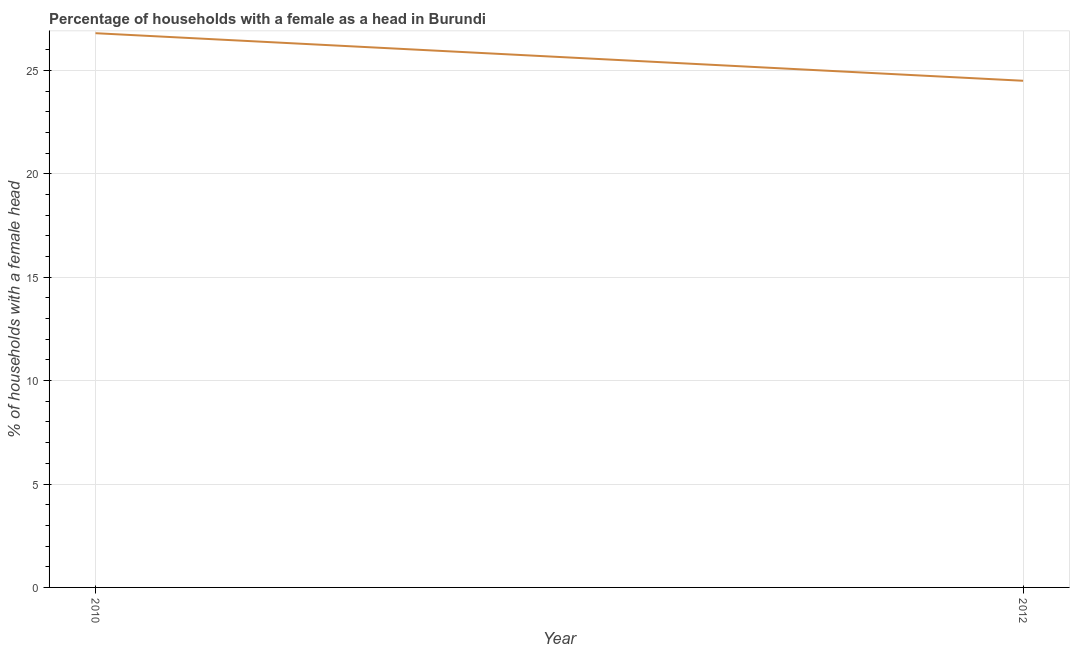Across all years, what is the maximum number of female supervised households?
Offer a very short reply. 26.8. Across all years, what is the minimum number of female supervised households?
Offer a very short reply. 24.5. In which year was the number of female supervised households minimum?
Give a very brief answer. 2012. What is the sum of the number of female supervised households?
Your answer should be compact. 51.3. What is the difference between the number of female supervised households in 2010 and 2012?
Keep it short and to the point. 2.3. What is the average number of female supervised households per year?
Offer a very short reply. 25.65. What is the median number of female supervised households?
Provide a succinct answer. 25.65. What is the ratio of the number of female supervised households in 2010 to that in 2012?
Provide a short and direct response. 1.09. Does the number of female supervised households monotonically increase over the years?
Your answer should be compact. No. How many lines are there?
Give a very brief answer. 1. How many years are there in the graph?
Give a very brief answer. 2. Are the values on the major ticks of Y-axis written in scientific E-notation?
Provide a succinct answer. No. Does the graph contain any zero values?
Your answer should be very brief. No. Does the graph contain grids?
Your answer should be compact. Yes. What is the title of the graph?
Keep it short and to the point. Percentage of households with a female as a head in Burundi. What is the label or title of the Y-axis?
Make the answer very short. % of households with a female head. What is the % of households with a female head of 2010?
Make the answer very short. 26.8. What is the difference between the % of households with a female head in 2010 and 2012?
Ensure brevity in your answer.  2.3. What is the ratio of the % of households with a female head in 2010 to that in 2012?
Provide a succinct answer. 1.09. 